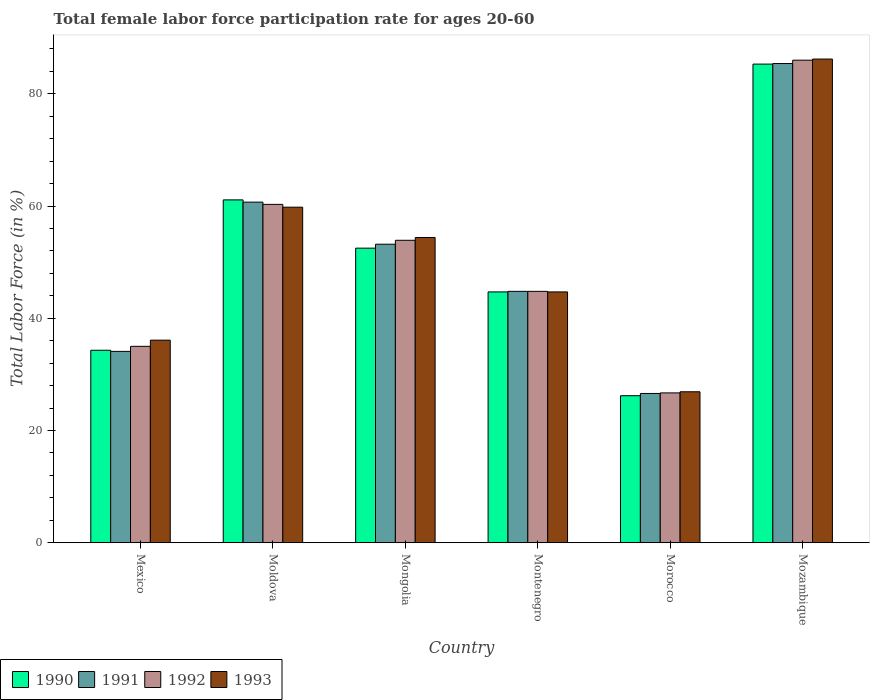How many groups of bars are there?
Keep it short and to the point. 6. Are the number of bars per tick equal to the number of legend labels?
Provide a short and direct response. Yes. What is the label of the 2nd group of bars from the left?
Ensure brevity in your answer.  Moldova. In how many cases, is the number of bars for a given country not equal to the number of legend labels?
Give a very brief answer. 0. What is the female labor force participation rate in 1990 in Mexico?
Your answer should be very brief. 34.3. Across all countries, what is the maximum female labor force participation rate in 1993?
Your answer should be very brief. 86.2. Across all countries, what is the minimum female labor force participation rate in 1993?
Offer a terse response. 26.9. In which country was the female labor force participation rate in 1992 maximum?
Ensure brevity in your answer.  Mozambique. In which country was the female labor force participation rate in 1990 minimum?
Give a very brief answer. Morocco. What is the total female labor force participation rate in 1992 in the graph?
Give a very brief answer. 306.7. What is the difference between the female labor force participation rate in 1993 in Mexico and that in Montenegro?
Provide a succinct answer. -8.6. What is the difference between the female labor force participation rate in 1990 in Mexico and the female labor force participation rate in 1991 in Morocco?
Make the answer very short. 7.7. What is the average female labor force participation rate in 1993 per country?
Keep it short and to the point. 51.35. In how many countries, is the female labor force participation rate in 1990 greater than 28 %?
Your response must be concise. 5. What is the ratio of the female labor force participation rate in 1990 in Moldova to that in Mongolia?
Ensure brevity in your answer.  1.16. What is the difference between the highest and the second highest female labor force participation rate in 1993?
Your answer should be compact. -5.4. What is the difference between the highest and the lowest female labor force participation rate in 1993?
Keep it short and to the point. 59.3. In how many countries, is the female labor force participation rate in 1992 greater than the average female labor force participation rate in 1992 taken over all countries?
Provide a short and direct response. 3. Is the sum of the female labor force participation rate in 1992 in Mongolia and Mozambique greater than the maximum female labor force participation rate in 1990 across all countries?
Provide a short and direct response. Yes. What does the 2nd bar from the right in Moldova represents?
Provide a short and direct response. 1992. How many bars are there?
Provide a short and direct response. 24. What is the difference between two consecutive major ticks on the Y-axis?
Keep it short and to the point. 20. Are the values on the major ticks of Y-axis written in scientific E-notation?
Your answer should be very brief. No. Does the graph contain any zero values?
Your response must be concise. No. How many legend labels are there?
Your answer should be very brief. 4. How are the legend labels stacked?
Your answer should be compact. Horizontal. What is the title of the graph?
Your response must be concise. Total female labor force participation rate for ages 20-60. Does "1973" appear as one of the legend labels in the graph?
Your answer should be very brief. No. What is the label or title of the Y-axis?
Ensure brevity in your answer.  Total Labor Force (in %). What is the Total Labor Force (in %) in 1990 in Mexico?
Ensure brevity in your answer.  34.3. What is the Total Labor Force (in %) in 1991 in Mexico?
Your answer should be very brief. 34.1. What is the Total Labor Force (in %) of 1993 in Mexico?
Give a very brief answer. 36.1. What is the Total Labor Force (in %) of 1990 in Moldova?
Offer a terse response. 61.1. What is the Total Labor Force (in %) in 1991 in Moldova?
Give a very brief answer. 60.7. What is the Total Labor Force (in %) of 1992 in Moldova?
Offer a very short reply. 60.3. What is the Total Labor Force (in %) of 1993 in Moldova?
Provide a succinct answer. 59.8. What is the Total Labor Force (in %) in 1990 in Mongolia?
Your answer should be very brief. 52.5. What is the Total Labor Force (in %) of 1991 in Mongolia?
Your answer should be compact. 53.2. What is the Total Labor Force (in %) in 1992 in Mongolia?
Your response must be concise. 53.9. What is the Total Labor Force (in %) in 1993 in Mongolia?
Your answer should be compact. 54.4. What is the Total Labor Force (in %) of 1990 in Montenegro?
Ensure brevity in your answer.  44.7. What is the Total Labor Force (in %) in 1991 in Montenegro?
Provide a short and direct response. 44.8. What is the Total Labor Force (in %) of 1992 in Montenegro?
Give a very brief answer. 44.8. What is the Total Labor Force (in %) in 1993 in Montenegro?
Keep it short and to the point. 44.7. What is the Total Labor Force (in %) in 1990 in Morocco?
Provide a succinct answer. 26.2. What is the Total Labor Force (in %) in 1991 in Morocco?
Your response must be concise. 26.6. What is the Total Labor Force (in %) in 1992 in Morocco?
Give a very brief answer. 26.7. What is the Total Labor Force (in %) of 1993 in Morocco?
Ensure brevity in your answer.  26.9. What is the Total Labor Force (in %) in 1990 in Mozambique?
Your answer should be compact. 85.3. What is the Total Labor Force (in %) of 1991 in Mozambique?
Give a very brief answer. 85.4. What is the Total Labor Force (in %) of 1992 in Mozambique?
Your response must be concise. 86. What is the Total Labor Force (in %) in 1993 in Mozambique?
Provide a succinct answer. 86.2. Across all countries, what is the maximum Total Labor Force (in %) in 1990?
Offer a very short reply. 85.3. Across all countries, what is the maximum Total Labor Force (in %) of 1991?
Provide a succinct answer. 85.4. Across all countries, what is the maximum Total Labor Force (in %) of 1993?
Your response must be concise. 86.2. Across all countries, what is the minimum Total Labor Force (in %) in 1990?
Keep it short and to the point. 26.2. Across all countries, what is the minimum Total Labor Force (in %) in 1991?
Ensure brevity in your answer.  26.6. Across all countries, what is the minimum Total Labor Force (in %) in 1992?
Your answer should be very brief. 26.7. Across all countries, what is the minimum Total Labor Force (in %) of 1993?
Keep it short and to the point. 26.9. What is the total Total Labor Force (in %) of 1990 in the graph?
Your answer should be very brief. 304.1. What is the total Total Labor Force (in %) of 1991 in the graph?
Your answer should be compact. 304.8. What is the total Total Labor Force (in %) of 1992 in the graph?
Offer a terse response. 306.7. What is the total Total Labor Force (in %) of 1993 in the graph?
Offer a very short reply. 308.1. What is the difference between the Total Labor Force (in %) in 1990 in Mexico and that in Moldova?
Provide a short and direct response. -26.8. What is the difference between the Total Labor Force (in %) in 1991 in Mexico and that in Moldova?
Offer a very short reply. -26.6. What is the difference between the Total Labor Force (in %) of 1992 in Mexico and that in Moldova?
Give a very brief answer. -25.3. What is the difference between the Total Labor Force (in %) in 1993 in Mexico and that in Moldova?
Offer a very short reply. -23.7. What is the difference between the Total Labor Force (in %) in 1990 in Mexico and that in Mongolia?
Give a very brief answer. -18.2. What is the difference between the Total Labor Force (in %) of 1991 in Mexico and that in Mongolia?
Offer a very short reply. -19.1. What is the difference between the Total Labor Force (in %) of 1992 in Mexico and that in Mongolia?
Keep it short and to the point. -18.9. What is the difference between the Total Labor Force (in %) in 1993 in Mexico and that in Mongolia?
Provide a short and direct response. -18.3. What is the difference between the Total Labor Force (in %) in 1993 in Mexico and that in Montenegro?
Provide a succinct answer. -8.6. What is the difference between the Total Labor Force (in %) of 1991 in Mexico and that in Morocco?
Make the answer very short. 7.5. What is the difference between the Total Labor Force (in %) of 1992 in Mexico and that in Morocco?
Your answer should be very brief. 8.3. What is the difference between the Total Labor Force (in %) of 1993 in Mexico and that in Morocco?
Offer a very short reply. 9.2. What is the difference between the Total Labor Force (in %) in 1990 in Mexico and that in Mozambique?
Your answer should be very brief. -51. What is the difference between the Total Labor Force (in %) of 1991 in Mexico and that in Mozambique?
Make the answer very short. -51.3. What is the difference between the Total Labor Force (in %) in 1992 in Mexico and that in Mozambique?
Give a very brief answer. -51. What is the difference between the Total Labor Force (in %) in 1993 in Mexico and that in Mozambique?
Offer a very short reply. -50.1. What is the difference between the Total Labor Force (in %) of 1990 in Moldova and that in Mongolia?
Provide a short and direct response. 8.6. What is the difference between the Total Labor Force (in %) in 1991 in Moldova and that in Mongolia?
Make the answer very short. 7.5. What is the difference between the Total Labor Force (in %) in 1993 in Moldova and that in Mongolia?
Ensure brevity in your answer.  5.4. What is the difference between the Total Labor Force (in %) of 1990 in Moldova and that in Montenegro?
Provide a succinct answer. 16.4. What is the difference between the Total Labor Force (in %) of 1990 in Moldova and that in Morocco?
Your answer should be very brief. 34.9. What is the difference between the Total Labor Force (in %) in 1991 in Moldova and that in Morocco?
Your response must be concise. 34.1. What is the difference between the Total Labor Force (in %) in 1992 in Moldova and that in Morocco?
Give a very brief answer. 33.6. What is the difference between the Total Labor Force (in %) of 1993 in Moldova and that in Morocco?
Your answer should be very brief. 32.9. What is the difference between the Total Labor Force (in %) in 1990 in Moldova and that in Mozambique?
Provide a short and direct response. -24.2. What is the difference between the Total Labor Force (in %) in 1991 in Moldova and that in Mozambique?
Provide a short and direct response. -24.7. What is the difference between the Total Labor Force (in %) in 1992 in Moldova and that in Mozambique?
Provide a short and direct response. -25.7. What is the difference between the Total Labor Force (in %) in 1993 in Moldova and that in Mozambique?
Give a very brief answer. -26.4. What is the difference between the Total Labor Force (in %) of 1990 in Mongolia and that in Montenegro?
Ensure brevity in your answer.  7.8. What is the difference between the Total Labor Force (in %) of 1990 in Mongolia and that in Morocco?
Your answer should be compact. 26.3. What is the difference between the Total Labor Force (in %) of 1991 in Mongolia and that in Morocco?
Ensure brevity in your answer.  26.6. What is the difference between the Total Labor Force (in %) of 1992 in Mongolia and that in Morocco?
Make the answer very short. 27.2. What is the difference between the Total Labor Force (in %) in 1990 in Mongolia and that in Mozambique?
Give a very brief answer. -32.8. What is the difference between the Total Labor Force (in %) in 1991 in Mongolia and that in Mozambique?
Give a very brief answer. -32.2. What is the difference between the Total Labor Force (in %) in 1992 in Mongolia and that in Mozambique?
Make the answer very short. -32.1. What is the difference between the Total Labor Force (in %) in 1993 in Mongolia and that in Mozambique?
Your answer should be compact. -31.8. What is the difference between the Total Labor Force (in %) of 1992 in Montenegro and that in Morocco?
Your answer should be very brief. 18.1. What is the difference between the Total Labor Force (in %) in 1990 in Montenegro and that in Mozambique?
Keep it short and to the point. -40.6. What is the difference between the Total Labor Force (in %) in 1991 in Montenegro and that in Mozambique?
Your response must be concise. -40.6. What is the difference between the Total Labor Force (in %) in 1992 in Montenegro and that in Mozambique?
Give a very brief answer. -41.2. What is the difference between the Total Labor Force (in %) in 1993 in Montenegro and that in Mozambique?
Keep it short and to the point. -41.5. What is the difference between the Total Labor Force (in %) of 1990 in Morocco and that in Mozambique?
Ensure brevity in your answer.  -59.1. What is the difference between the Total Labor Force (in %) of 1991 in Morocco and that in Mozambique?
Your response must be concise. -58.8. What is the difference between the Total Labor Force (in %) in 1992 in Morocco and that in Mozambique?
Provide a succinct answer. -59.3. What is the difference between the Total Labor Force (in %) in 1993 in Morocco and that in Mozambique?
Give a very brief answer. -59.3. What is the difference between the Total Labor Force (in %) of 1990 in Mexico and the Total Labor Force (in %) of 1991 in Moldova?
Ensure brevity in your answer.  -26.4. What is the difference between the Total Labor Force (in %) in 1990 in Mexico and the Total Labor Force (in %) in 1993 in Moldova?
Provide a short and direct response. -25.5. What is the difference between the Total Labor Force (in %) in 1991 in Mexico and the Total Labor Force (in %) in 1992 in Moldova?
Give a very brief answer. -26.2. What is the difference between the Total Labor Force (in %) of 1991 in Mexico and the Total Labor Force (in %) of 1993 in Moldova?
Ensure brevity in your answer.  -25.7. What is the difference between the Total Labor Force (in %) of 1992 in Mexico and the Total Labor Force (in %) of 1993 in Moldova?
Offer a very short reply. -24.8. What is the difference between the Total Labor Force (in %) of 1990 in Mexico and the Total Labor Force (in %) of 1991 in Mongolia?
Offer a very short reply. -18.9. What is the difference between the Total Labor Force (in %) of 1990 in Mexico and the Total Labor Force (in %) of 1992 in Mongolia?
Keep it short and to the point. -19.6. What is the difference between the Total Labor Force (in %) of 1990 in Mexico and the Total Labor Force (in %) of 1993 in Mongolia?
Offer a terse response. -20.1. What is the difference between the Total Labor Force (in %) of 1991 in Mexico and the Total Labor Force (in %) of 1992 in Mongolia?
Make the answer very short. -19.8. What is the difference between the Total Labor Force (in %) of 1991 in Mexico and the Total Labor Force (in %) of 1993 in Mongolia?
Your answer should be compact. -20.3. What is the difference between the Total Labor Force (in %) in 1992 in Mexico and the Total Labor Force (in %) in 1993 in Mongolia?
Your answer should be very brief. -19.4. What is the difference between the Total Labor Force (in %) in 1990 in Mexico and the Total Labor Force (in %) in 1991 in Montenegro?
Give a very brief answer. -10.5. What is the difference between the Total Labor Force (in %) in 1991 in Mexico and the Total Labor Force (in %) in 1992 in Montenegro?
Make the answer very short. -10.7. What is the difference between the Total Labor Force (in %) in 1992 in Mexico and the Total Labor Force (in %) in 1993 in Montenegro?
Make the answer very short. -9.7. What is the difference between the Total Labor Force (in %) of 1990 in Mexico and the Total Labor Force (in %) of 1993 in Morocco?
Your answer should be compact. 7.4. What is the difference between the Total Labor Force (in %) of 1991 in Mexico and the Total Labor Force (in %) of 1992 in Morocco?
Ensure brevity in your answer.  7.4. What is the difference between the Total Labor Force (in %) of 1991 in Mexico and the Total Labor Force (in %) of 1993 in Morocco?
Offer a terse response. 7.2. What is the difference between the Total Labor Force (in %) of 1992 in Mexico and the Total Labor Force (in %) of 1993 in Morocco?
Give a very brief answer. 8.1. What is the difference between the Total Labor Force (in %) of 1990 in Mexico and the Total Labor Force (in %) of 1991 in Mozambique?
Provide a succinct answer. -51.1. What is the difference between the Total Labor Force (in %) of 1990 in Mexico and the Total Labor Force (in %) of 1992 in Mozambique?
Your answer should be compact. -51.7. What is the difference between the Total Labor Force (in %) of 1990 in Mexico and the Total Labor Force (in %) of 1993 in Mozambique?
Provide a short and direct response. -51.9. What is the difference between the Total Labor Force (in %) of 1991 in Mexico and the Total Labor Force (in %) of 1992 in Mozambique?
Your answer should be very brief. -51.9. What is the difference between the Total Labor Force (in %) of 1991 in Mexico and the Total Labor Force (in %) of 1993 in Mozambique?
Your answer should be compact. -52.1. What is the difference between the Total Labor Force (in %) of 1992 in Mexico and the Total Labor Force (in %) of 1993 in Mozambique?
Offer a terse response. -51.2. What is the difference between the Total Labor Force (in %) in 1990 in Moldova and the Total Labor Force (in %) in 1992 in Mongolia?
Make the answer very short. 7.2. What is the difference between the Total Labor Force (in %) of 1991 in Moldova and the Total Labor Force (in %) of 1992 in Mongolia?
Provide a succinct answer. 6.8. What is the difference between the Total Labor Force (in %) of 1990 in Moldova and the Total Labor Force (in %) of 1992 in Montenegro?
Offer a terse response. 16.3. What is the difference between the Total Labor Force (in %) of 1990 in Moldova and the Total Labor Force (in %) of 1991 in Morocco?
Make the answer very short. 34.5. What is the difference between the Total Labor Force (in %) of 1990 in Moldova and the Total Labor Force (in %) of 1992 in Morocco?
Provide a short and direct response. 34.4. What is the difference between the Total Labor Force (in %) in 1990 in Moldova and the Total Labor Force (in %) in 1993 in Morocco?
Make the answer very short. 34.2. What is the difference between the Total Labor Force (in %) in 1991 in Moldova and the Total Labor Force (in %) in 1992 in Morocco?
Ensure brevity in your answer.  34. What is the difference between the Total Labor Force (in %) of 1991 in Moldova and the Total Labor Force (in %) of 1993 in Morocco?
Your answer should be compact. 33.8. What is the difference between the Total Labor Force (in %) in 1992 in Moldova and the Total Labor Force (in %) in 1993 in Morocco?
Offer a terse response. 33.4. What is the difference between the Total Labor Force (in %) in 1990 in Moldova and the Total Labor Force (in %) in 1991 in Mozambique?
Provide a short and direct response. -24.3. What is the difference between the Total Labor Force (in %) in 1990 in Moldova and the Total Labor Force (in %) in 1992 in Mozambique?
Provide a short and direct response. -24.9. What is the difference between the Total Labor Force (in %) in 1990 in Moldova and the Total Labor Force (in %) in 1993 in Mozambique?
Ensure brevity in your answer.  -25.1. What is the difference between the Total Labor Force (in %) in 1991 in Moldova and the Total Labor Force (in %) in 1992 in Mozambique?
Give a very brief answer. -25.3. What is the difference between the Total Labor Force (in %) in 1991 in Moldova and the Total Labor Force (in %) in 1993 in Mozambique?
Give a very brief answer. -25.5. What is the difference between the Total Labor Force (in %) of 1992 in Moldova and the Total Labor Force (in %) of 1993 in Mozambique?
Keep it short and to the point. -25.9. What is the difference between the Total Labor Force (in %) of 1990 in Mongolia and the Total Labor Force (in %) of 1993 in Montenegro?
Provide a succinct answer. 7.8. What is the difference between the Total Labor Force (in %) of 1991 in Mongolia and the Total Labor Force (in %) of 1992 in Montenegro?
Make the answer very short. 8.4. What is the difference between the Total Labor Force (in %) of 1991 in Mongolia and the Total Labor Force (in %) of 1993 in Montenegro?
Provide a succinct answer. 8.5. What is the difference between the Total Labor Force (in %) of 1990 in Mongolia and the Total Labor Force (in %) of 1991 in Morocco?
Provide a succinct answer. 25.9. What is the difference between the Total Labor Force (in %) in 1990 in Mongolia and the Total Labor Force (in %) in 1992 in Morocco?
Ensure brevity in your answer.  25.8. What is the difference between the Total Labor Force (in %) in 1990 in Mongolia and the Total Labor Force (in %) in 1993 in Morocco?
Provide a short and direct response. 25.6. What is the difference between the Total Labor Force (in %) in 1991 in Mongolia and the Total Labor Force (in %) in 1992 in Morocco?
Offer a very short reply. 26.5. What is the difference between the Total Labor Force (in %) of 1991 in Mongolia and the Total Labor Force (in %) of 1993 in Morocco?
Your answer should be compact. 26.3. What is the difference between the Total Labor Force (in %) of 1992 in Mongolia and the Total Labor Force (in %) of 1993 in Morocco?
Offer a very short reply. 27. What is the difference between the Total Labor Force (in %) of 1990 in Mongolia and the Total Labor Force (in %) of 1991 in Mozambique?
Ensure brevity in your answer.  -32.9. What is the difference between the Total Labor Force (in %) in 1990 in Mongolia and the Total Labor Force (in %) in 1992 in Mozambique?
Provide a succinct answer. -33.5. What is the difference between the Total Labor Force (in %) in 1990 in Mongolia and the Total Labor Force (in %) in 1993 in Mozambique?
Offer a very short reply. -33.7. What is the difference between the Total Labor Force (in %) in 1991 in Mongolia and the Total Labor Force (in %) in 1992 in Mozambique?
Give a very brief answer. -32.8. What is the difference between the Total Labor Force (in %) of 1991 in Mongolia and the Total Labor Force (in %) of 1993 in Mozambique?
Your answer should be compact. -33. What is the difference between the Total Labor Force (in %) in 1992 in Mongolia and the Total Labor Force (in %) in 1993 in Mozambique?
Offer a very short reply. -32.3. What is the difference between the Total Labor Force (in %) in 1990 in Montenegro and the Total Labor Force (in %) in 1991 in Morocco?
Your response must be concise. 18.1. What is the difference between the Total Labor Force (in %) of 1991 in Montenegro and the Total Labor Force (in %) of 1992 in Morocco?
Provide a succinct answer. 18.1. What is the difference between the Total Labor Force (in %) of 1991 in Montenegro and the Total Labor Force (in %) of 1993 in Morocco?
Make the answer very short. 17.9. What is the difference between the Total Labor Force (in %) of 1992 in Montenegro and the Total Labor Force (in %) of 1993 in Morocco?
Ensure brevity in your answer.  17.9. What is the difference between the Total Labor Force (in %) in 1990 in Montenegro and the Total Labor Force (in %) in 1991 in Mozambique?
Keep it short and to the point. -40.7. What is the difference between the Total Labor Force (in %) of 1990 in Montenegro and the Total Labor Force (in %) of 1992 in Mozambique?
Give a very brief answer. -41.3. What is the difference between the Total Labor Force (in %) of 1990 in Montenegro and the Total Labor Force (in %) of 1993 in Mozambique?
Offer a very short reply. -41.5. What is the difference between the Total Labor Force (in %) of 1991 in Montenegro and the Total Labor Force (in %) of 1992 in Mozambique?
Your response must be concise. -41.2. What is the difference between the Total Labor Force (in %) in 1991 in Montenegro and the Total Labor Force (in %) in 1993 in Mozambique?
Offer a terse response. -41.4. What is the difference between the Total Labor Force (in %) of 1992 in Montenegro and the Total Labor Force (in %) of 1993 in Mozambique?
Your response must be concise. -41.4. What is the difference between the Total Labor Force (in %) in 1990 in Morocco and the Total Labor Force (in %) in 1991 in Mozambique?
Your response must be concise. -59.2. What is the difference between the Total Labor Force (in %) in 1990 in Morocco and the Total Labor Force (in %) in 1992 in Mozambique?
Ensure brevity in your answer.  -59.8. What is the difference between the Total Labor Force (in %) in 1990 in Morocco and the Total Labor Force (in %) in 1993 in Mozambique?
Your answer should be compact. -60. What is the difference between the Total Labor Force (in %) in 1991 in Morocco and the Total Labor Force (in %) in 1992 in Mozambique?
Make the answer very short. -59.4. What is the difference between the Total Labor Force (in %) in 1991 in Morocco and the Total Labor Force (in %) in 1993 in Mozambique?
Your answer should be very brief. -59.6. What is the difference between the Total Labor Force (in %) of 1992 in Morocco and the Total Labor Force (in %) of 1993 in Mozambique?
Give a very brief answer. -59.5. What is the average Total Labor Force (in %) in 1990 per country?
Provide a short and direct response. 50.68. What is the average Total Labor Force (in %) in 1991 per country?
Give a very brief answer. 50.8. What is the average Total Labor Force (in %) of 1992 per country?
Ensure brevity in your answer.  51.12. What is the average Total Labor Force (in %) in 1993 per country?
Provide a short and direct response. 51.35. What is the difference between the Total Labor Force (in %) in 1990 and Total Labor Force (in %) in 1991 in Mexico?
Your answer should be very brief. 0.2. What is the difference between the Total Labor Force (in %) in 1990 and Total Labor Force (in %) in 1992 in Mexico?
Ensure brevity in your answer.  -0.7. What is the difference between the Total Labor Force (in %) of 1992 and Total Labor Force (in %) of 1993 in Mexico?
Ensure brevity in your answer.  -1.1. What is the difference between the Total Labor Force (in %) in 1990 and Total Labor Force (in %) in 1991 in Moldova?
Your answer should be very brief. 0.4. What is the difference between the Total Labor Force (in %) in 1990 and Total Labor Force (in %) in 1992 in Moldova?
Your response must be concise. 0.8. What is the difference between the Total Labor Force (in %) of 1990 and Total Labor Force (in %) of 1993 in Moldova?
Give a very brief answer. 1.3. What is the difference between the Total Labor Force (in %) of 1991 and Total Labor Force (in %) of 1993 in Moldova?
Your answer should be compact. 0.9. What is the difference between the Total Labor Force (in %) in 1992 and Total Labor Force (in %) in 1993 in Moldova?
Provide a short and direct response. 0.5. What is the difference between the Total Labor Force (in %) of 1990 and Total Labor Force (in %) of 1992 in Mongolia?
Your response must be concise. -1.4. What is the difference between the Total Labor Force (in %) of 1991 and Total Labor Force (in %) of 1993 in Mongolia?
Give a very brief answer. -1.2. What is the difference between the Total Labor Force (in %) in 1991 and Total Labor Force (in %) in 1993 in Montenegro?
Give a very brief answer. 0.1. What is the difference between the Total Labor Force (in %) in 1990 and Total Labor Force (in %) in 1991 in Morocco?
Provide a short and direct response. -0.4. What is the difference between the Total Labor Force (in %) in 1991 and Total Labor Force (in %) in 1993 in Morocco?
Offer a terse response. -0.3. What is the difference between the Total Labor Force (in %) in 1992 and Total Labor Force (in %) in 1993 in Morocco?
Provide a short and direct response. -0.2. What is the difference between the Total Labor Force (in %) of 1990 and Total Labor Force (in %) of 1993 in Mozambique?
Offer a very short reply. -0.9. What is the difference between the Total Labor Force (in %) of 1991 and Total Labor Force (in %) of 1992 in Mozambique?
Provide a succinct answer. -0.6. What is the difference between the Total Labor Force (in %) in 1992 and Total Labor Force (in %) in 1993 in Mozambique?
Provide a short and direct response. -0.2. What is the ratio of the Total Labor Force (in %) in 1990 in Mexico to that in Moldova?
Ensure brevity in your answer.  0.56. What is the ratio of the Total Labor Force (in %) in 1991 in Mexico to that in Moldova?
Make the answer very short. 0.56. What is the ratio of the Total Labor Force (in %) of 1992 in Mexico to that in Moldova?
Make the answer very short. 0.58. What is the ratio of the Total Labor Force (in %) in 1993 in Mexico to that in Moldova?
Provide a succinct answer. 0.6. What is the ratio of the Total Labor Force (in %) in 1990 in Mexico to that in Mongolia?
Ensure brevity in your answer.  0.65. What is the ratio of the Total Labor Force (in %) of 1991 in Mexico to that in Mongolia?
Your answer should be very brief. 0.64. What is the ratio of the Total Labor Force (in %) of 1992 in Mexico to that in Mongolia?
Offer a very short reply. 0.65. What is the ratio of the Total Labor Force (in %) in 1993 in Mexico to that in Mongolia?
Ensure brevity in your answer.  0.66. What is the ratio of the Total Labor Force (in %) in 1990 in Mexico to that in Montenegro?
Offer a terse response. 0.77. What is the ratio of the Total Labor Force (in %) in 1991 in Mexico to that in Montenegro?
Ensure brevity in your answer.  0.76. What is the ratio of the Total Labor Force (in %) in 1992 in Mexico to that in Montenegro?
Provide a short and direct response. 0.78. What is the ratio of the Total Labor Force (in %) of 1993 in Mexico to that in Montenegro?
Give a very brief answer. 0.81. What is the ratio of the Total Labor Force (in %) in 1990 in Mexico to that in Morocco?
Your response must be concise. 1.31. What is the ratio of the Total Labor Force (in %) of 1991 in Mexico to that in Morocco?
Provide a succinct answer. 1.28. What is the ratio of the Total Labor Force (in %) of 1992 in Mexico to that in Morocco?
Give a very brief answer. 1.31. What is the ratio of the Total Labor Force (in %) in 1993 in Mexico to that in Morocco?
Your answer should be very brief. 1.34. What is the ratio of the Total Labor Force (in %) in 1990 in Mexico to that in Mozambique?
Make the answer very short. 0.4. What is the ratio of the Total Labor Force (in %) of 1991 in Mexico to that in Mozambique?
Give a very brief answer. 0.4. What is the ratio of the Total Labor Force (in %) of 1992 in Mexico to that in Mozambique?
Your answer should be very brief. 0.41. What is the ratio of the Total Labor Force (in %) of 1993 in Mexico to that in Mozambique?
Provide a succinct answer. 0.42. What is the ratio of the Total Labor Force (in %) in 1990 in Moldova to that in Mongolia?
Your answer should be very brief. 1.16. What is the ratio of the Total Labor Force (in %) of 1991 in Moldova to that in Mongolia?
Your response must be concise. 1.14. What is the ratio of the Total Labor Force (in %) of 1992 in Moldova to that in Mongolia?
Offer a very short reply. 1.12. What is the ratio of the Total Labor Force (in %) of 1993 in Moldova to that in Mongolia?
Provide a short and direct response. 1.1. What is the ratio of the Total Labor Force (in %) of 1990 in Moldova to that in Montenegro?
Ensure brevity in your answer.  1.37. What is the ratio of the Total Labor Force (in %) of 1991 in Moldova to that in Montenegro?
Provide a short and direct response. 1.35. What is the ratio of the Total Labor Force (in %) of 1992 in Moldova to that in Montenegro?
Your answer should be very brief. 1.35. What is the ratio of the Total Labor Force (in %) of 1993 in Moldova to that in Montenegro?
Keep it short and to the point. 1.34. What is the ratio of the Total Labor Force (in %) in 1990 in Moldova to that in Morocco?
Offer a terse response. 2.33. What is the ratio of the Total Labor Force (in %) of 1991 in Moldova to that in Morocco?
Your answer should be compact. 2.28. What is the ratio of the Total Labor Force (in %) in 1992 in Moldova to that in Morocco?
Provide a short and direct response. 2.26. What is the ratio of the Total Labor Force (in %) of 1993 in Moldova to that in Morocco?
Keep it short and to the point. 2.22. What is the ratio of the Total Labor Force (in %) of 1990 in Moldova to that in Mozambique?
Your answer should be very brief. 0.72. What is the ratio of the Total Labor Force (in %) of 1991 in Moldova to that in Mozambique?
Provide a short and direct response. 0.71. What is the ratio of the Total Labor Force (in %) in 1992 in Moldova to that in Mozambique?
Provide a short and direct response. 0.7. What is the ratio of the Total Labor Force (in %) of 1993 in Moldova to that in Mozambique?
Offer a terse response. 0.69. What is the ratio of the Total Labor Force (in %) in 1990 in Mongolia to that in Montenegro?
Offer a terse response. 1.17. What is the ratio of the Total Labor Force (in %) of 1991 in Mongolia to that in Montenegro?
Your response must be concise. 1.19. What is the ratio of the Total Labor Force (in %) in 1992 in Mongolia to that in Montenegro?
Offer a terse response. 1.2. What is the ratio of the Total Labor Force (in %) in 1993 in Mongolia to that in Montenegro?
Offer a terse response. 1.22. What is the ratio of the Total Labor Force (in %) of 1990 in Mongolia to that in Morocco?
Your answer should be compact. 2. What is the ratio of the Total Labor Force (in %) in 1992 in Mongolia to that in Morocco?
Keep it short and to the point. 2.02. What is the ratio of the Total Labor Force (in %) of 1993 in Mongolia to that in Morocco?
Provide a succinct answer. 2.02. What is the ratio of the Total Labor Force (in %) of 1990 in Mongolia to that in Mozambique?
Your response must be concise. 0.62. What is the ratio of the Total Labor Force (in %) of 1991 in Mongolia to that in Mozambique?
Provide a succinct answer. 0.62. What is the ratio of the Total Labor Force (in %) of 1992 in Mongolia to that in Mozambique?
Keep it short and to the point. 0.63. What is the ratio of the Total Labor Force (in %) in 1993 in Mongolia to that in Mozambique?
Provide a short and direct response. 0.63. What is the ratio of the Total Labor Force (in %) in 1990 in Montenegro to that in Morocco?
Give a very brief answer. 1.71. What is the ratio of the Total Labor Force (in %) of 1991 in Montenegro to that in Morocco?
Give a very brief answer. 1.68. What is the ratio of the Total Labor Force (in %) of 1992 in Montenegro to that in Morocco?
Offer a terse response. 1.68. What is the ratio of the Total Labor Force (in %) in 1993 in Montenegro to that in Morocco?
Ensure brevity in your answer.  1.66. What is the ratio of the Total Labor Force (in %) in 1990 in Montenegro to that in Mozambique?
Keep it short and to the point. 0.52. What is the ratio of the Total Labor Force (in %) in 1991 in Montenegro to that in Mozambique?
Make the answer very short. 0.52. What is the ratio of the Total Labor Force (in %) in 1992 in Montenegro to that in Mozambique?
Ensure brevity in your answer.  0.52. What is the ratio of the Total Labor Force (in %) of 1993 in Montenegro to that in Mozambique?
Offer a very short reply. 0.52. What is the ratio of the Total Labor Force (in %) in 1990 in Morocco to that in Mozambique?
Make the answer very short. 0.31. What is the ratio of the Total Labor Force (in %) of 1991 in Morocco to that in Mozambique?
Give a very brief answer. 0.31. What is the ratio of the Total Labor Force (in %) of 1992 in Morocco to that in Mozambique?
Your answer should be compact. 0.31. What is the ratio of the Total Labor Force (in %) of 1993 in Morocco to that in Mozambique?
Offer a very short reply. 0.31. What is the difference between the highest and the second highest Total Labor Force (in %) in 1990?
Give a very brief answer. 24.2. What is the difference between the highest and the second highest Total Labor Force (in %) in 1991?
Provide a short and direct response. 24.7. What is the difference between the highest and the second highest Total Labor Force (in %) of 1992?
Your answer should be very brief. 25.7. What is the difference between the highest and the second highest Total Labor Force (in %) in 1993?
Provide a succinct answer. 26.4. What is the difference between the highest and the lowest Total Labor Force (in %) of 1990?
Offer a very short reply. 59.1. What is the difference between the highest and the lowest Total Labor Force (in %) in 1991?
Your answer should be compact. 58.8. What is the difference between the highest and the lowest Total Labor Force (in %) in 1992?
Make the answer very short. 59.3. What is the difference between the highest and the lowest Total Labor Force (in %) of 1993?
Your response must be concise. 59.3. 